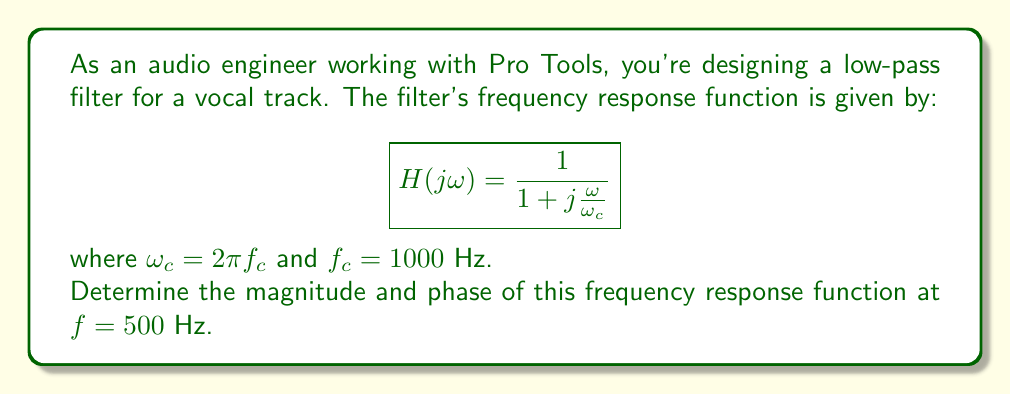Can you solve this math problem? To solve this problem, we'll follow these steps:

1) First, we need to calculate $\omega$ and $\omega_c$:
   
   $\omega_c = 2\pi f_c = 2\pi(1000) = 2000\pi$ rad/s
   $\omega = 2\pi f = 2\pi(500) = 1000\pi$ rad/s

2) Now, let's substitute these values into our frequency response function:

   $$H(j\omega) = \frac{1}{1 + j\frac{1000\pi}{2000\pi}} = \frac{1}{1 + j\frac{1}{2}}$$

3) To find the magnitude, we use the formula:
   
   $$|H(j\omega)| = \sqrt{\frac{1}{1^2 + (\frac{1}{2})^2}} = \frac{1}{\sqrt{1 + \frac{1}{4}}} = \frac{2}{\sqrt{5}}$$

4) To find the phase, we use the formula:
   
   $$\angle H(j\omega) = -\tan^{-1}(\frac{1}{2}) = -\arctan(0.5)$$

5) Converting the phase to degrees:

   $$-\arctan(0.5) * \frac{180}{\pi} \approx -26.57°$$
Answer: Magnitude: $\frac{2}{\sqrt{5}} \approx 0.8944$
Phase: $-26.57°$ 